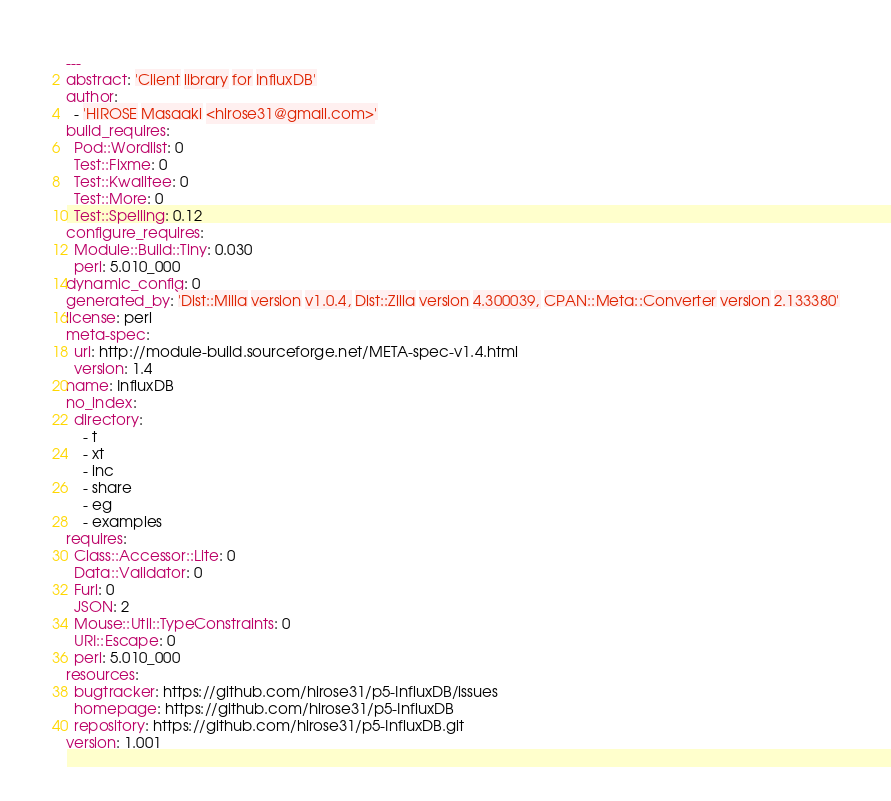<code> <loc_0><loc_0><loc_500><loc_500><_YAML_>---
abstract: 'Client library for InfluxDB'
author:
  - 'HIROSE Masaaki <hirose31@gmail.com>'
build_requires:
  Pod::Wordlist: 0
  Test::Fixme: 0
  Test::Kwalitee: 0
  Test::More: 0
  Test::Spelling: 0.12
configure_requires:
  Module::Build::Tiny: 0.030
  perl: 5.010_000
dynamic_config: 0
generated_by: 'Dist::Milla version v1.0.4, Dist::Zilla version 4.300039, CPAN::Meta::Converter version 2.133380'
license: perl
meta-spec:
  url: http://module-build.sourceforge.net/META-spec-v1.4.html
  version: 1.4
name: InfluxDB
no_index:
  directory:
    - t
    - xt
    - inc
    - share
    - eg
    - examples
requires:
  Class::Accessor::Lite: 0
  Data::Validator: 0
  Furl: 0
  JSON: 2
  Mouse::Util::TypeConstraints: 0
  URI::Escape: 0
  perl: 5.010_000
resources:
  bugtracker: https://github.com/hirose31/p5-InfluxDB/issues
  homepage: https://github.com/hirose31/p5-InfluxDB
  repository: https://github.com/hirose31/p5-InfluxDB.git
version: 1.001
</code> 